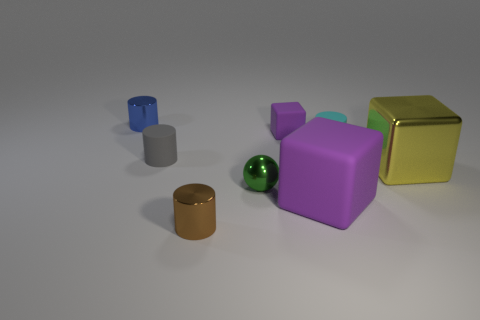How many purple blocks must be subtracted to get 1 purple blocks? 1 Add 1 tiny rubber things. How many objects exist? 9 Subtract all large purple blocks. How many blocks are left? 2 Subtract all purple blocks. How many blocks are left? 1 Subtract 1 cylinders. How many cylinders are left? 3 Add 1 large purple cubes. How many large purple cubes are left? 2 Add 1 yellow objects. How many yellow objects exist? 2 Subtract 1 cyan cylinders. How many objects are left? 7 Subtract all balls. How many objects are left? 7 Subtract all red cylinders. Subtract all yellow balls. How many cylinders are left? 4 